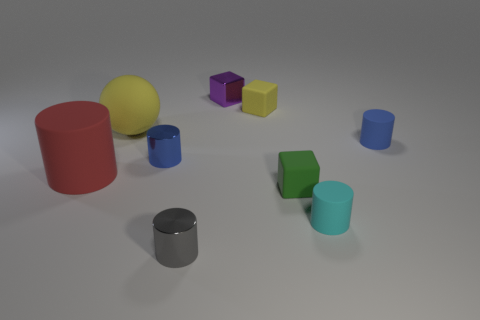Are there any patterns or alignments of colors among the objects? The objects do not exhibit a specific pattern or alignment in terms of colors. However, there is a noticeable distribution where similar shapes are not of the same color, which provides a variety of hues throughout the composition. This diversity in color helps distinguish each geometric shape individually. 